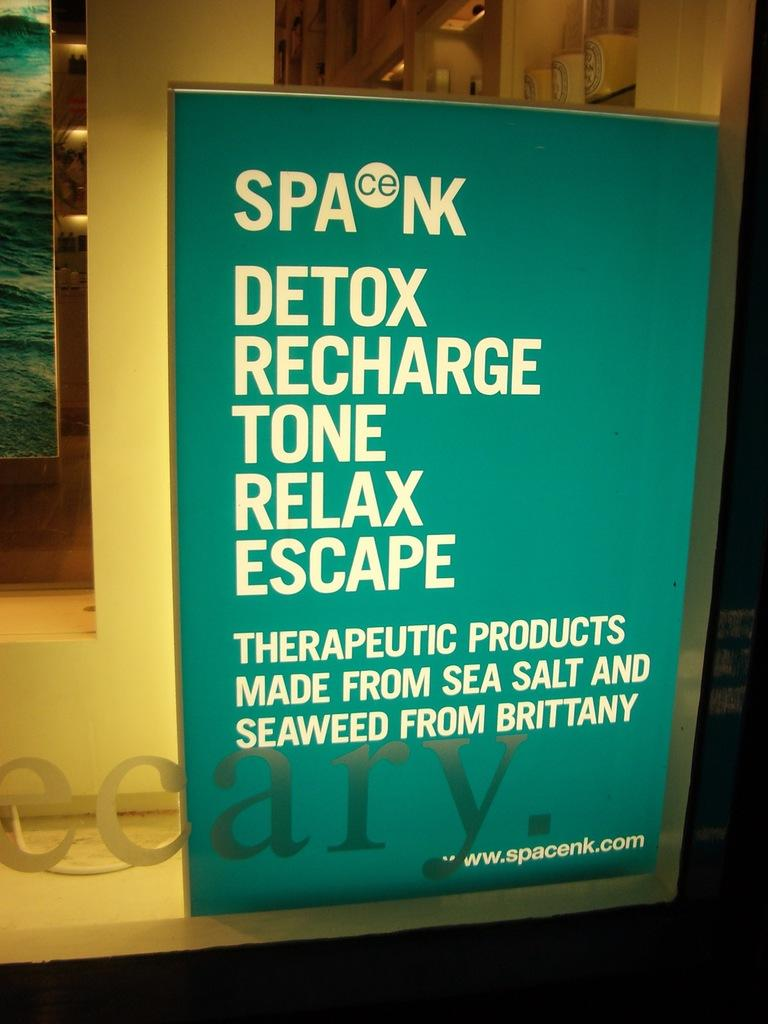<image>
Create a compact narrative representing the image presented. A sign that says detox recharge tone relax escape. 